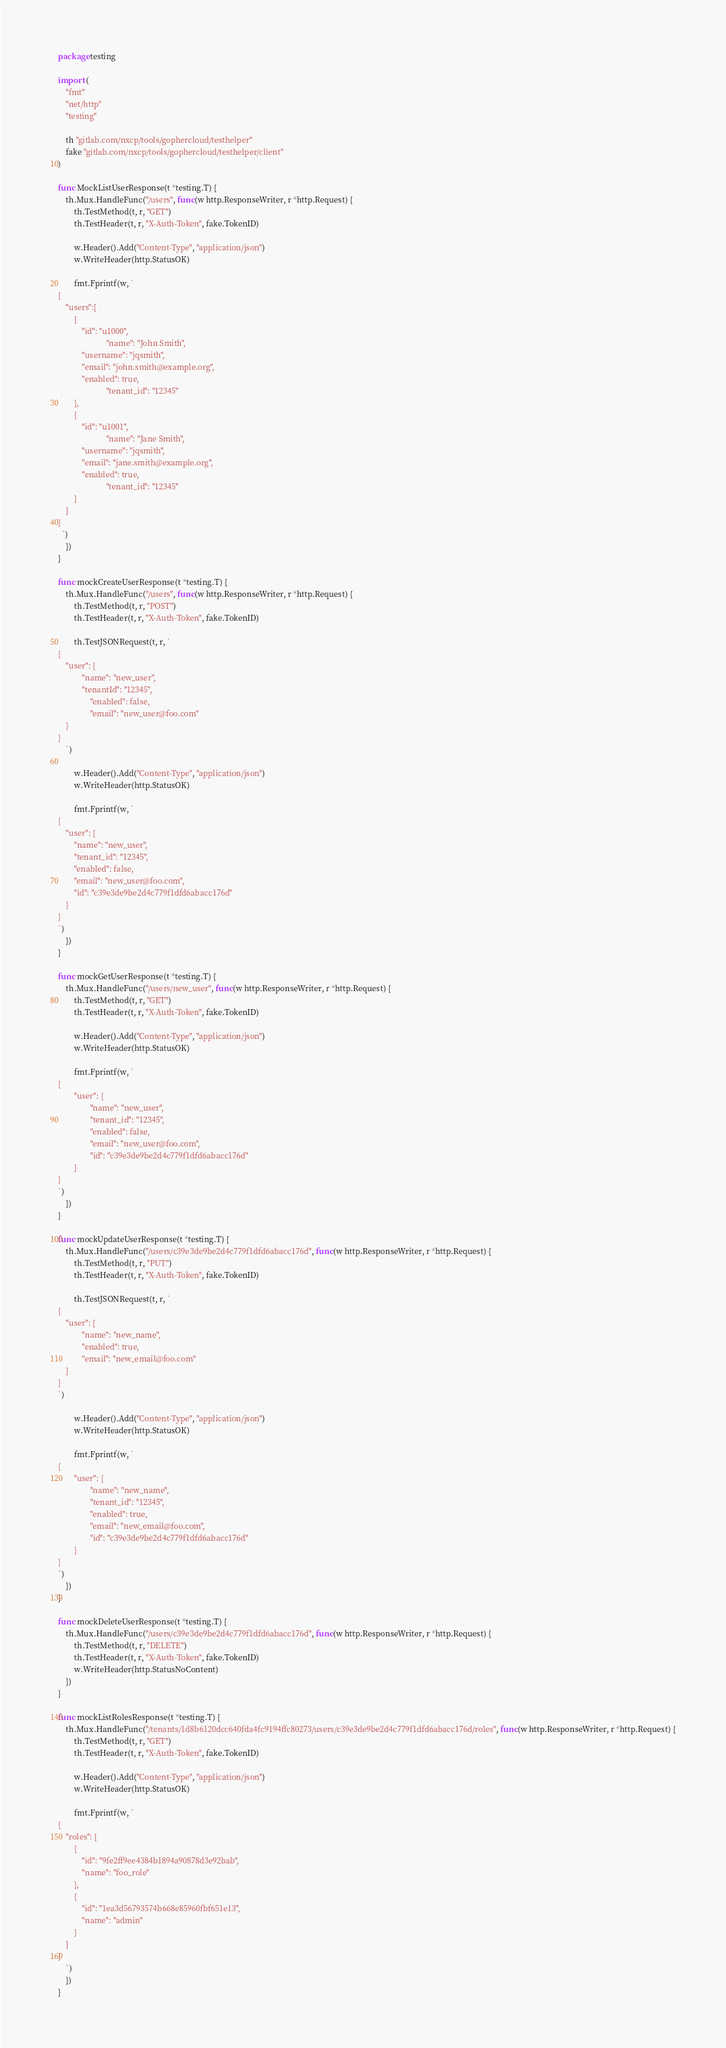Convert code to text. <code><loc_0><loc_0><loc_500><loc_500><_Go_>package testing

import (
	"fmt"
	"net/http"
	"testing"

	th "gitlab.com/nxcp/tools/gophercloud/testhelper"
	fake "gitlab.com/nxcp/tools/gophercloud/testhelper/client"
)

func MockListUserResponse(t *testing.T) {
	th.Mux.HandleFunc("/users", func(w http.ResponseWriter, r *http.Request) {
		th.TestMethod(t, r, "GET")
		th.TestHeader(t, r, "X-Auth-Token", fake.TokenID)

		w.Header().Add("Content-Type", "application/json")
		w.WriteHeader(http.StatusOK)

		fmt.Fprintf(w, `
{
    "users":[
        {
            "id": "u1000",
						"name": "John Smith",
            "username": "jqsmith",
            "email": "john.smith@example.org",
            "enabled": true,
						"tenant_id": "12345"
        },
        {
            "id": "u1001",
						"name": "Jane Smith",
            "username": "jqsmith",
            "email": "jane.smith@example.org",
            "enabled": true,
						"tenant_id": "12345"
        }
    ]
}
  `)
	})
}

func mockCreateUserResponse(t *testing.T) {
	th.Mux.HandleFunc("/users", func(w http.ResponseWriter, r *http.Request) {
		th.TestMethod(t, r, "POST")
		th.TestHeader(t, r, "X-Auth-Token", fake.TokenID)

		th.TestJSONRequest(t, r, `
{
    "user": {
		    "name": "new_user",
		    "tenantId": "12345",
				"enabled": false,
				"email": "new_user@foo.com"
    }
}
	`)

		w.Header().Add("Content-Type", "application/json")
		w.WriteHeader(http.StatusOK)

		fmt.Fprintf(w, `
{
    "user": {
        "name": "new_user",
        "tenant_id": "12345",
        "enabled": false,
        "email": "new_user@foo.com",
        "id": "c39e3de9be2d4c779f1dfd6abacc176d"
    }
}
`)
	})
}

func mockGetUserResponse(t *testing.T) {
	th.Mux.HandleFunc("/users/new_user", func(w http.ResponseWriter, r *http.Request) {
		th.TestMethod(t, r, "GET")
		th.TestHeader(t, r, "X-Auth-Token", fake.TokenID)

		w.Header().Add("Content-Type", "application/json")
		w.WriteHeader(http.StatusOK)

		fmt.Fprintf(w, `
{
		"user": {
				"name": "new_user",
				"tenant_id": "12345",
				"enabled": false,
				"email": "new_user@foo.com",
				"id": "c39e3de9be2d4c779f1dfd6abacc176d"
		}
}
`)
	})
}

func mockUpdateUserResponse(t *testing.T) {
	th.Mux.HandleFunc("/users/c39e3de9be2d4c779f1dfd6abacc176d", func(w http.ResponseWriter, r *http.Request) {
		th.TestMethod(t, r, "PUT")
		th.TestHeader(t, r, "X-Auth-Token", fake.TokenID)

		th.TestJSONRequest(t, r, `
{
    "user": {
		    "name": "new_name",
		    "enabled": true,
		    "email": "new_email@foo.com"
    }
}
`)

		w.Header().Add("Content-Type", "application/json")
		w.WriteHeader(http.StatusOK)

		fmt.Fprintf(w, `
{
		"user": {
				"name": "new_name",
				"tenant_id": "12345",
				"enabled": true,
				"email": "new_email@foo.com",
				"id": "c39e3de9be2d4c779f1dfd6abacc176d"
		}
}
`)
	})
}

func mockDeleteUserResponse(t *testing.T) {
	th.Mux.HandleFunc("/users/c39e3de9be2d4c779f1dfd6abacc176d", func(w http.ResponseWriter, r *http.Request) {
		th.TestMethod(t, r, "DELETE")
		th.TestHeader(t, r, "X-Auth-Token", fake.TokenID)
		w.WriteHeader(http.StatusNoContent)
	})
}

func mockListRolesResponse(t *testing.T) {
	th.Mux.HandleFunc("/tenants/1d8b6120dcc640fda4fc9194ffc80273/users/c39e3de9be2d4c779f1dfd6abacc176d/roles", func(w http.ResponseWriter, r *http.Request) {
		th.TestMethod(t, r, "GET")
		th.TestHeader(t, r, "X-Auth-Token", fake.TokenID)

		w.Header().Add("Content-Type", "application/json")
		w.WriteHeader(http.StatusOK)

		fmt.Fprintf(w, `
{
    "roles": [
        {
            "id": "9fe2ff9ee4384b1894a90878d3e92bab",
            "name": "foo_role"
        },
        {
            "id": "1ea3d56793574b668e85960fbf651e13",
            "name": "admin"
        }
    ]
}
	`)
	})
}
</code> 